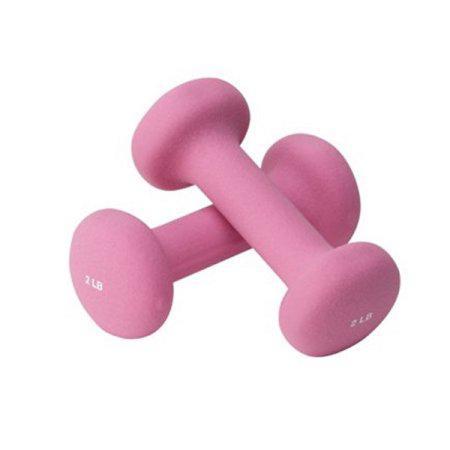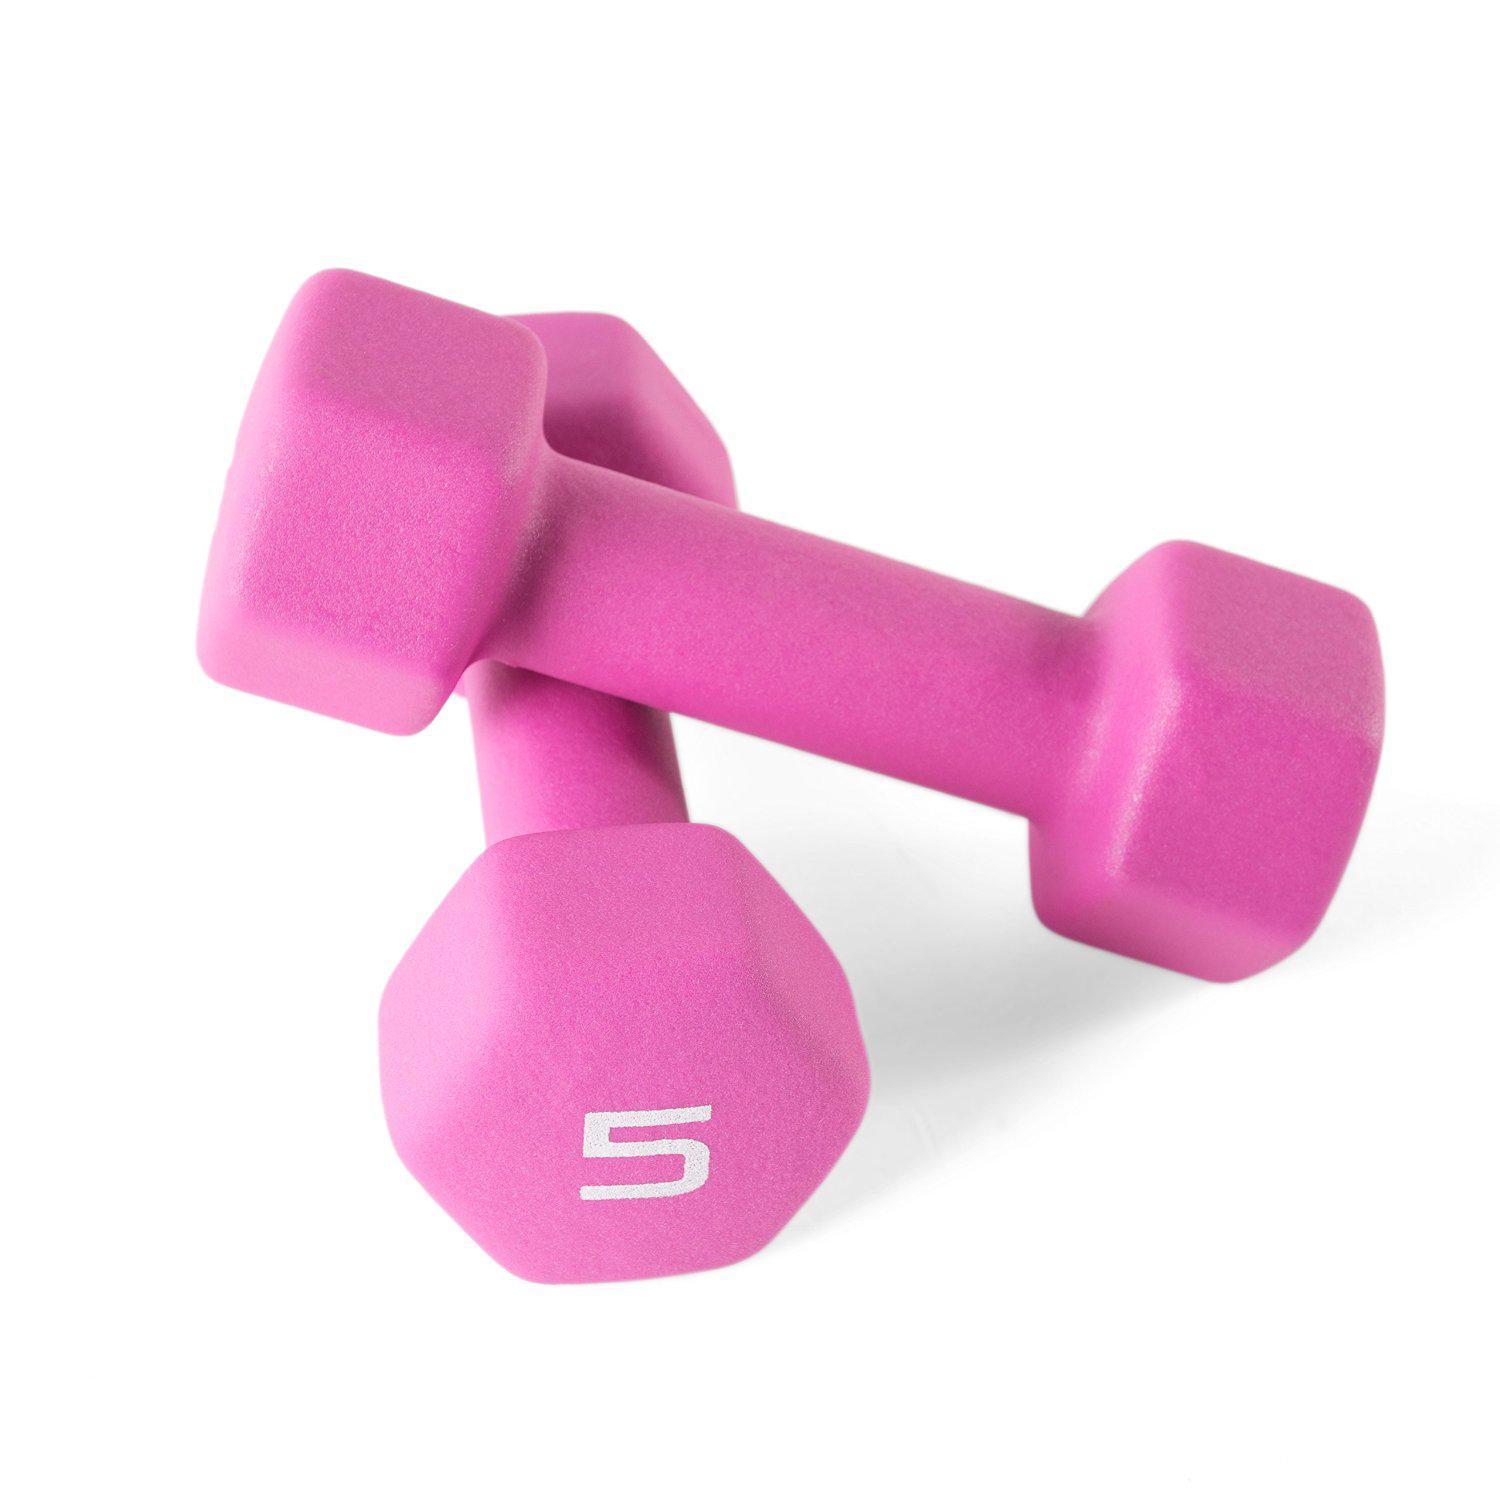The first image is the image on the left, the second image is the image on the right. For the images shown, is this caption "In each image, one dumbbell is leaning against another." true? Answer yes or no. Yes. The first image is the image on the left, the second image is the image on the right. Analyze the images presented: Is the assertion "There are four dumbbells." valid? Answer yes or no. Yes. 